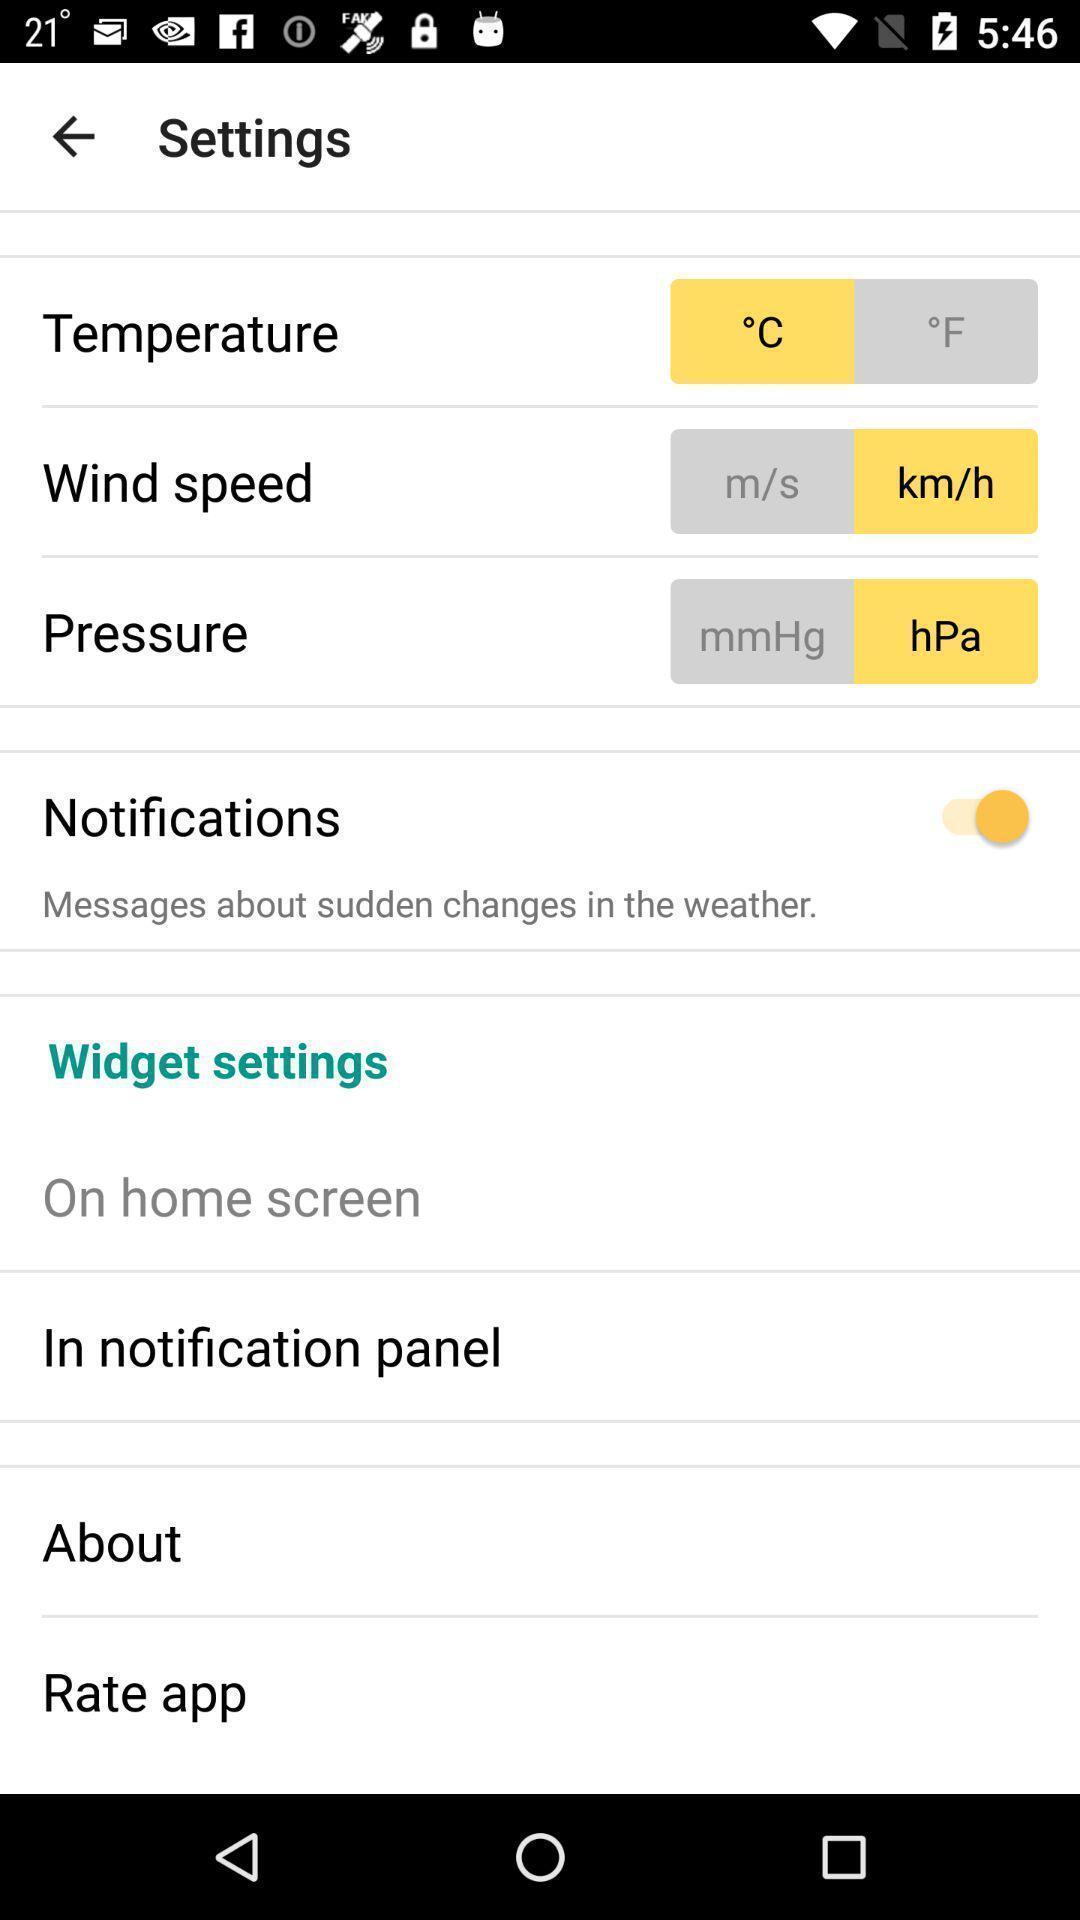Provide a description of this screenshot. Settings page. 